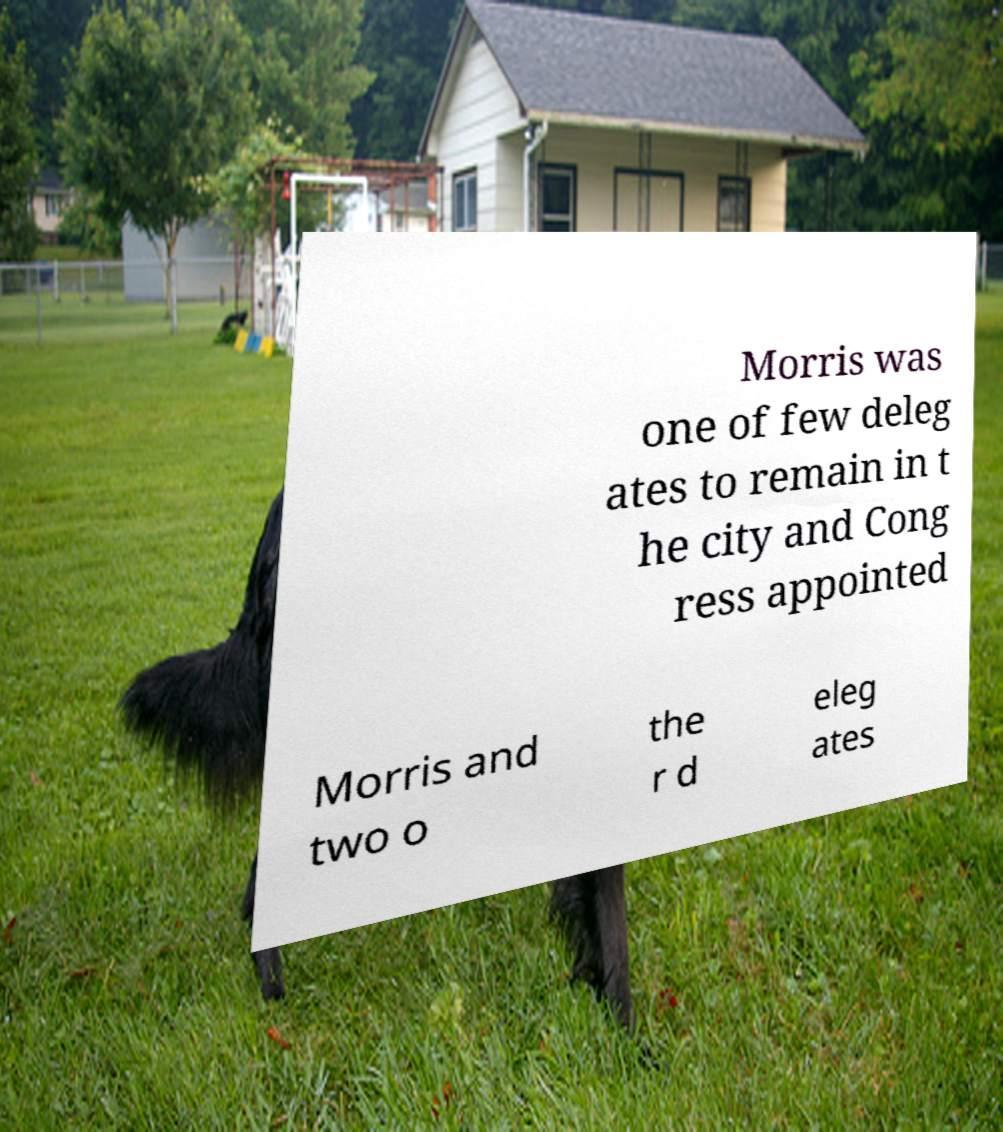Could you assist in decoding the text presented in this image and type it out clearly? Morris was one of few deleg ates to remain in t he city and Cong ress appointed Morris and two o the r d eleg ates 